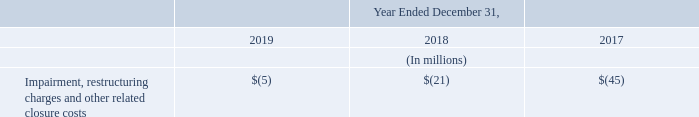In 2019 we recorded $5 million of impairment, restructuring charges and other related closure costs, mainly consisting of impairment of equipment and licenses dedicated exclusively to certain development projects that were cancelled, while no alternative future use was identified internally.
In 2018 we recorded $21 million of impairment, restructuring charges and other related closure costs, consisting of: (i) $19 million related to the set-top box restructuring plan and (ii) $2 million of impairment of acquired technologies, for which it was determined that they had no future alternative use.
In 2017 we recorded $45 million of impairment, restructuring charges and other related closure costs, primarily consisting of: (i) $34 million of net restructuring charges related to the set-top box restructuring plan; (ii) $13 million of restructuring charges related to the restructuring plan in Bouskoura, Morocco;
(iii) $3 million charge relating to the update of the existing unused lease provision and (iv) $5 million income for the reversal of provisions related to previously announced restructuring plans, mainly the Embedded Processing Solutions business restructuring plan, for which accrued provisions were not fully used at completion of the plan.
In 2019, what constituted Impairment, restructuring charges and other related closure costs? Mainly consisting of impairment of equipment and licenses dedicated exclusively to certain development projects that were cancelled, while no alternative future use was identified internally. In 2018, what constituted Impairment, restructuring charges and other related closure costs? (i) $19 million related to the set-top box restructuring plan and (ii) $2 million of impairment of acquired technologies, for which it was determined that they had no future alternative use. How much was the net restructuring charges related to the set-top box restructuring plan in 2017? $34 million. What is the average Impairment, restructuring charges and other related closure costs?
Answer scale should be: million. (5+21+45) / 3
Answer: 23.67. What is the increase/ (decrease) in Impairment, restructuring charges and other related closure costs from 2017 to 2019?
Answer scale should be: million. 5-45
Answer: -40. What is the increase/ (decrease) in Impairment, restructuring charges and other related closure costs from 2017 to 2018?
Answer scale should be: million. 21-45
Answer: -24. 